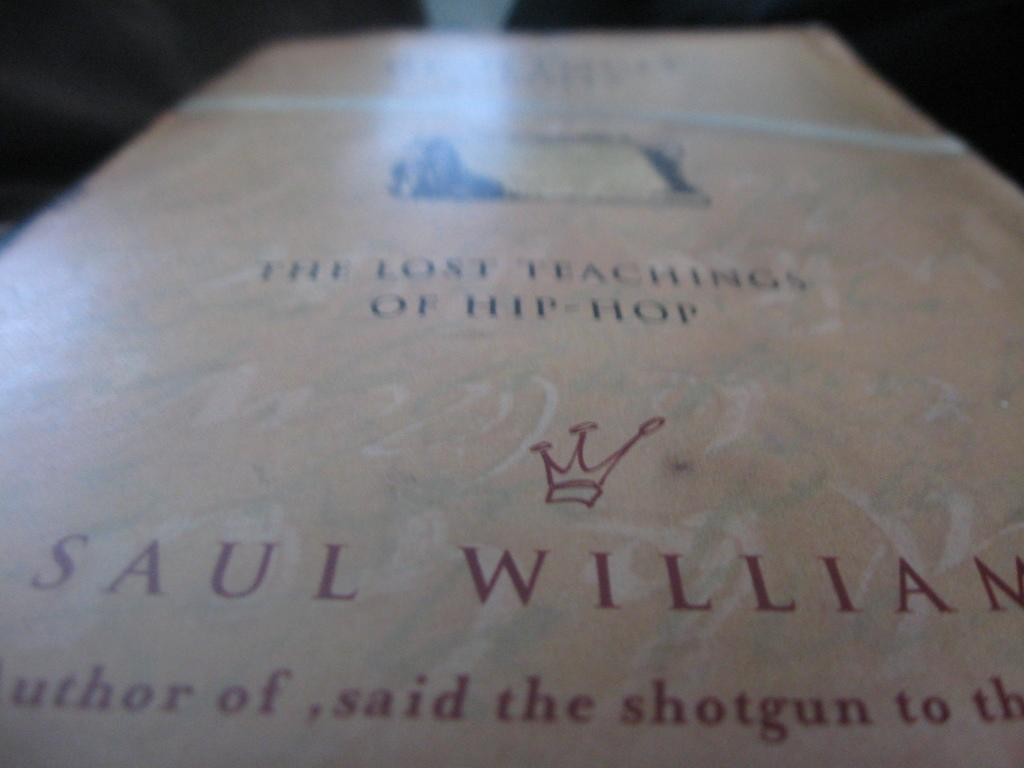<image>
Offer a succinct explanation of the picture presented. Red crown that has the words Lost Teaching of Hip Hop lying on a table. 